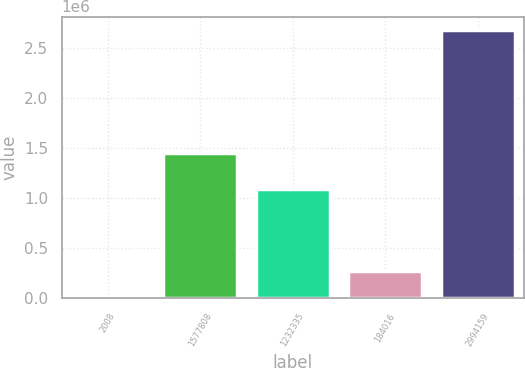<chart> <loc_0><loc_0><loc_500><loc_500><bar_chart><fcel>2008<fcel>1577808<fcel>1232335<fcel>184016<fcel>2994159<nl><fcel>2007<fcel>1.45262e+06<fcel>1.09183e+06<fcel>269380<fcel>2.67573e+06<nl></chart> 